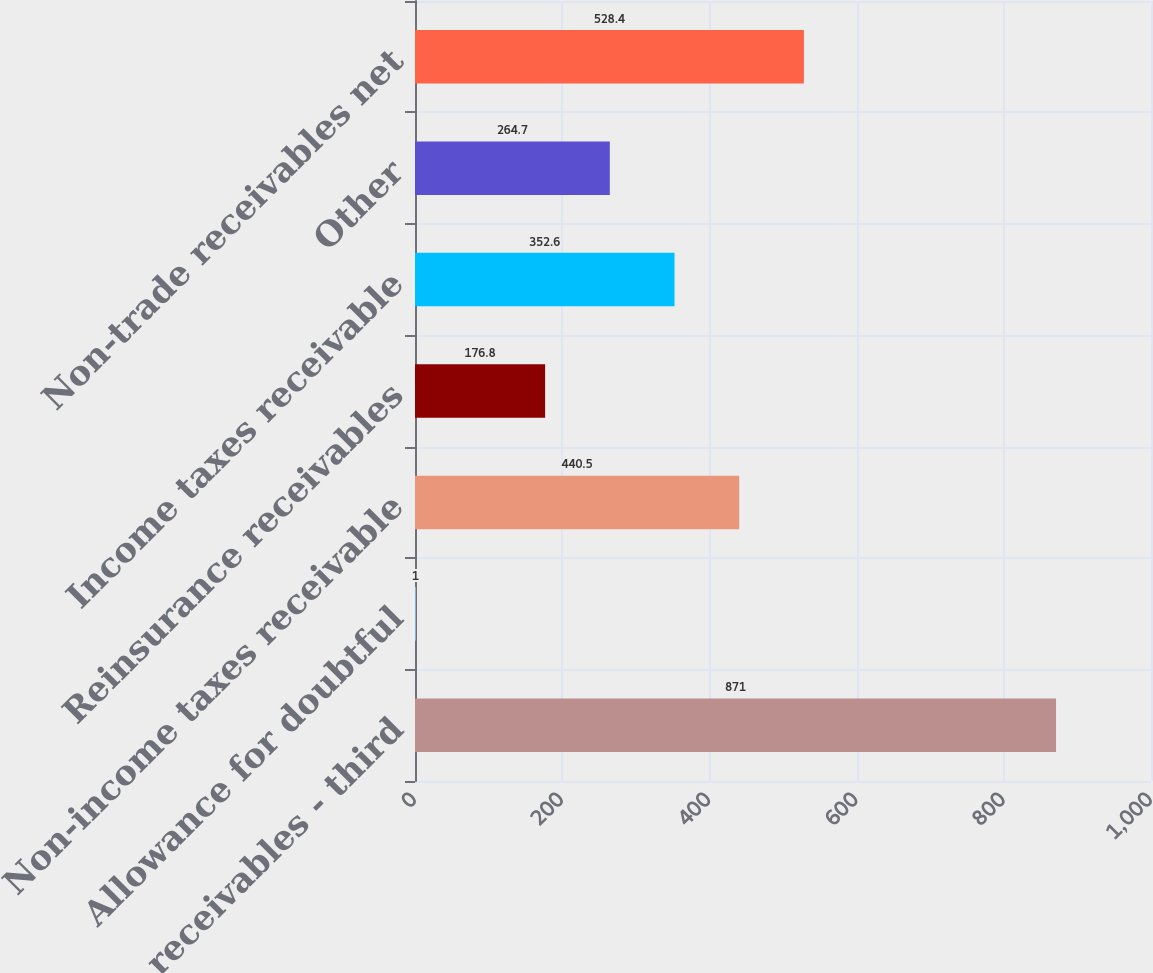Convert chart. <chart><loc_0><loc_0><loc_500><loc_500><bar_chart><fcel>Trade receivables - third<fcel>Allowance for doubtful<fcel>Non-income taxes receivable<fcel>Reinsurance receivables<fcel>Income taxes receivable<fcel>Other<fcel>Non-trade receivables net<nl><fcel>871<fcel>1<fcel>440.5<fcel>176.8<fcel>352.6<fcel>264.7<fcel>528.4<nl></chart> 